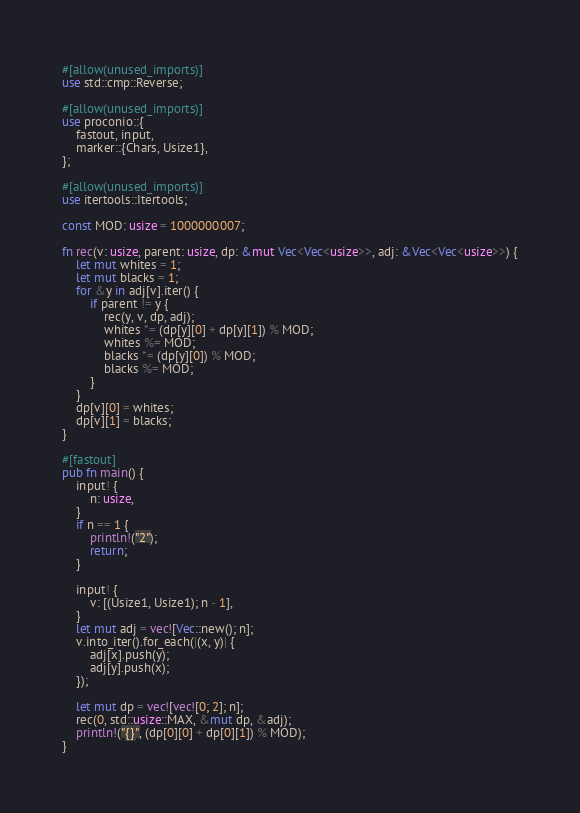<code> <loc_0><loc_0><loc_500><loc_500><_Rust_>#[allow(unused_imports)]
use std::cmp::Reverse;

#[allow(unused_imports)]
use proconio::{
    fastout, input,
    marker::{Chars, Usize1},
};

#[allow(unused_imports)]
use itertools::Itertools;

const MOD: usize = 1000000007;

fn rec(v: usize, parent: usize, dp: &mut Vec<Vec<usize>>, adj: &Vec<Vec<usize>>) {
    let mut whites = 1;
    let mut blacks = 1;
    for &y in adj[v].iter() {
        if parent != y {
            rec(y, v, dp, adj);
            whites *= (dp[y][0] + dp[y][1]) % MOD;
            whites %= MOD;
            blacks *= (dp[y][0]) % MOD;
            blacks %= MOD;
        }
    }
    dp[v][0] = whites;
    dp[v][1] = blacks;
}

#[fastout]
pub fn main() {
    input! {
        n: usize,
    }
    if n == 1 {
        println!("2");
        return;
    }

    input! {
        v: [(Usize1, Usize1); n - 1],
    }
    let mut adj = vec![Vec::new(); n];
    v.into_iter().for_each(|(x, y)| {
        adj[x].push(y);
        adj[y].push(x);
    });

    let mut dp = vec![vec![0; 2]; n];
    rec(0, std::usize::MAX, &mut dp, &adj);
    println!("{}", (dp[0][0] + dp[0][1]) % MOD);
}
</code> 